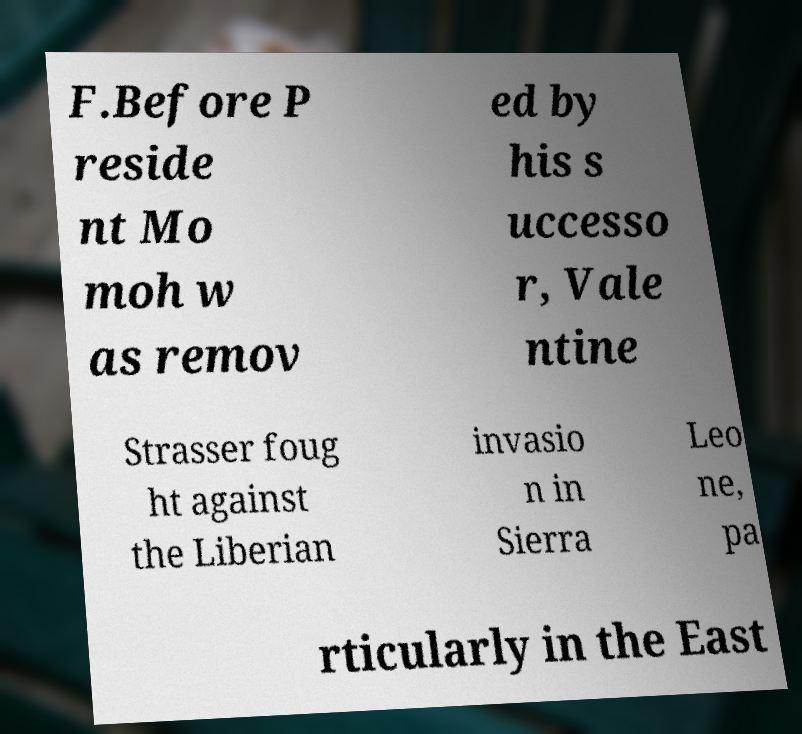Please read and relay the text visible in this image. What does it say? F.Before P reside nt Mo moh w as remov ed by his s uccesso r, Vale ntine Strasser foug ht against the Liberian invasio n in Sierra Leo ne, pa rticularly in the East 